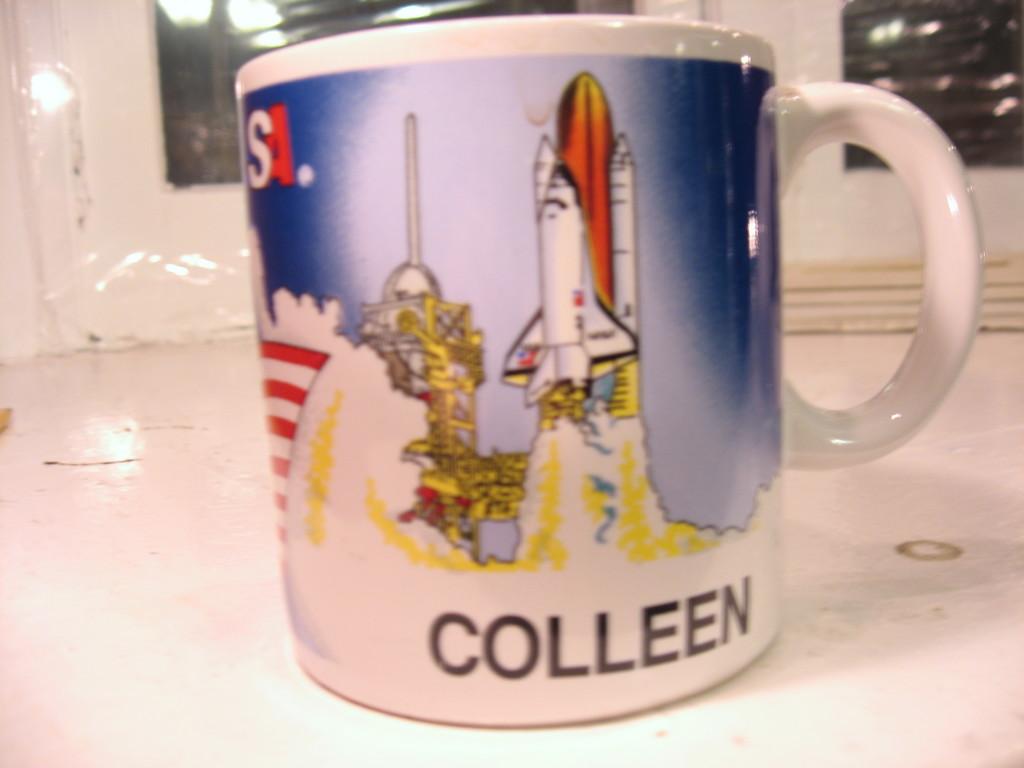Who's name is on the cup?
Offer a terse response. Colleen. 